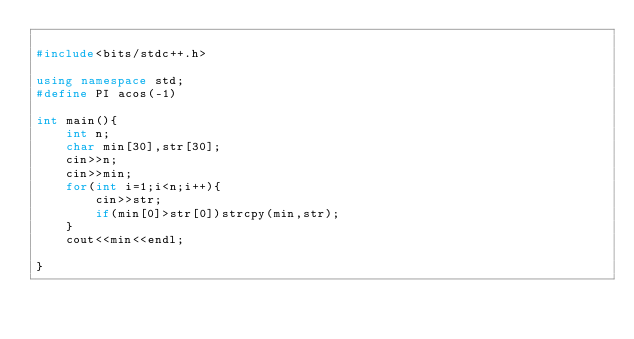Convert code to text. <code><loc_0><loc_0><loc_500><loc_500><_C++_>
#include<bits/stdc++.h>

using namespace std;
#define PI acos(-1)

int main(){
	int n;
	char min[30],str[30];
	cin>>n;
	cin>>min;
	for(int i=1;i<n;i++){
		cin>>str;
		if(min[0]>str[0])strcpy(min,str);
	}
	cout<<min<<endl;
	
}</code> 